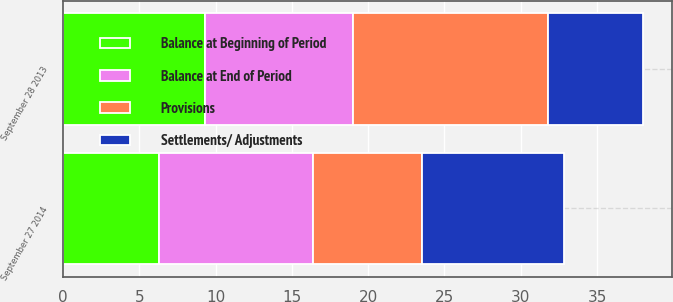<chart> <loc_0><loc_0><loc_500><loc_500><stacked_bar_chart><ecel><fcel>September 27 2014<fcel>September 28 2013<nl><fcel>Settlements/ Adjustments<fcel>9.3<fcel>6.2<nl><fcel>Provisions<fcel>7.1<fcel>12.8<nl><fcel>Balance at End of Period<fcel>10.1<fcel>9.7<nl><fcel>Balance at Beginning of Period<fcel>6.3<fcel>9.3<nl></chart> 